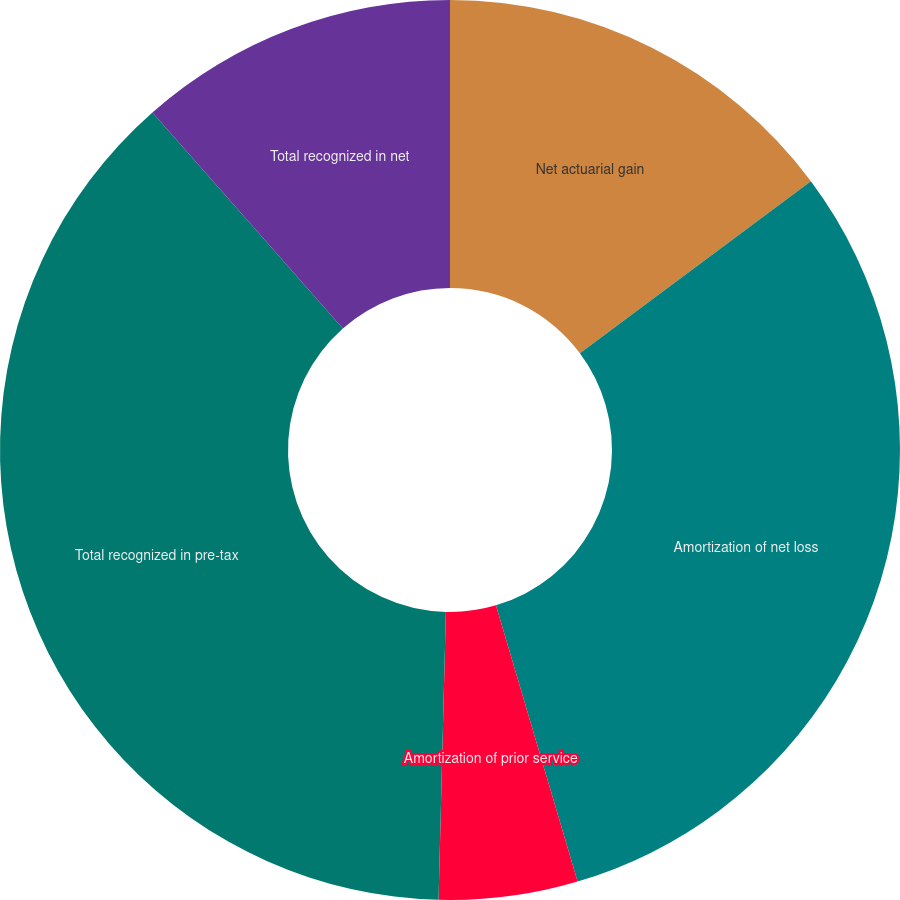Convert chart to OTSL. <chart><loc_0><loc_0><loc_500><loc_500><pie_chart><fcel>Net actuarial gain<fcel>Amortization of net loss<fcel>Amortization of prior service<fcel>Total recognized in pre-tax<fcel>Total recognized in net<nl><fcel>14.81%<fcel>30.61%<fcel>4.98%<fcel>38.09%<fcel>11.5%<nl></chart> 